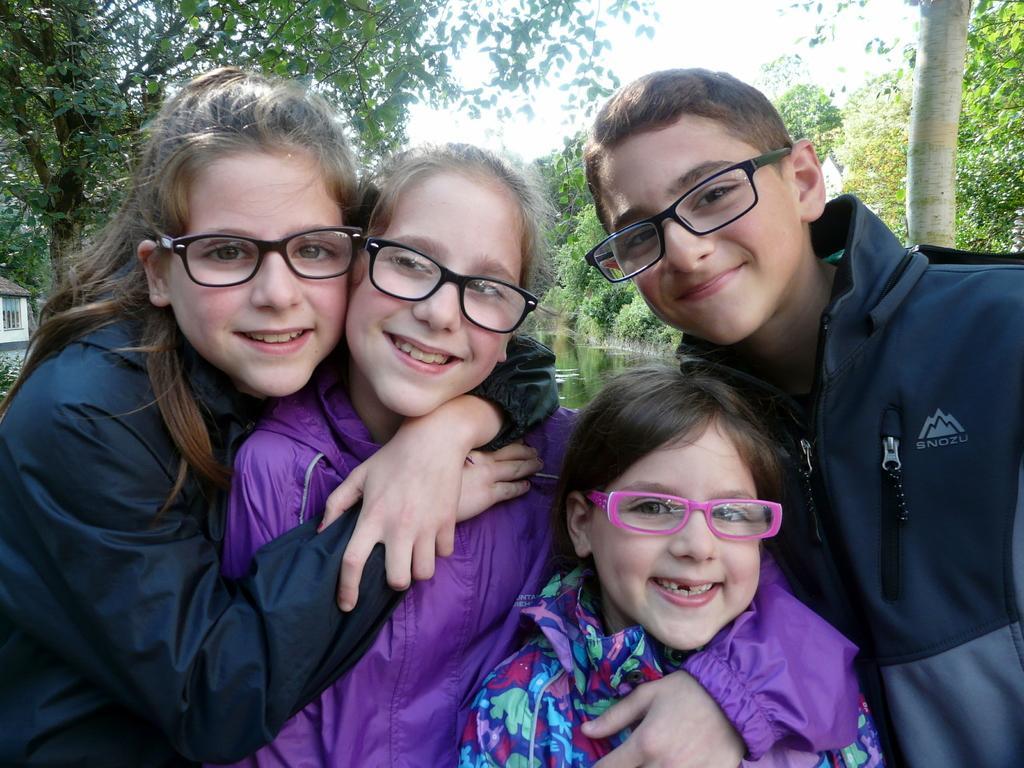In one or two sentences, can you explain what this image depicts? In this picture i can see four people are wearing spectacles and smiling and in the background i can see trees. 